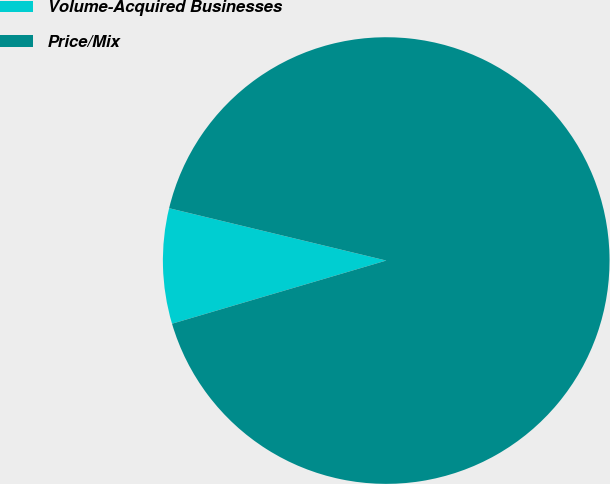Convert chart to OTSL. <chart><loc_0><loc_0><loc_500><loc_500><pie_chart><fcel>Volume-Acquired Businesses<fcel>Price/Mix<nl><fcel>8.33%<fcel>91.67%<nl></chart> 